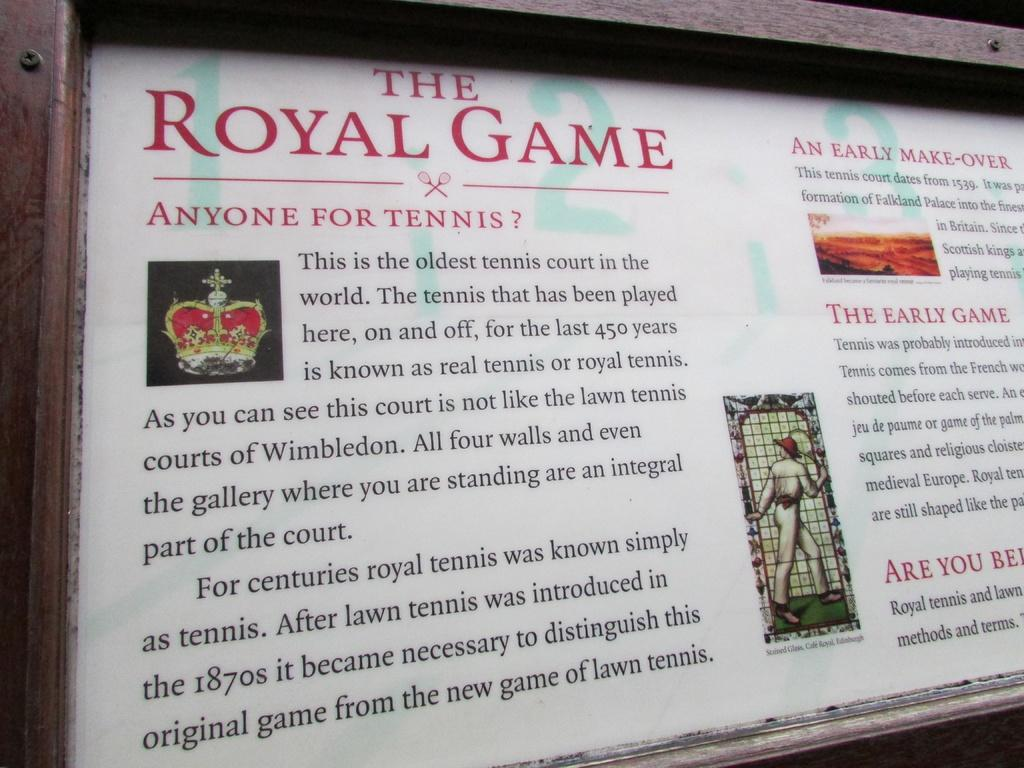<image>
Present a compact description of the photo's key features. A large frame has a print in it with red writing that says The Royal Game. 